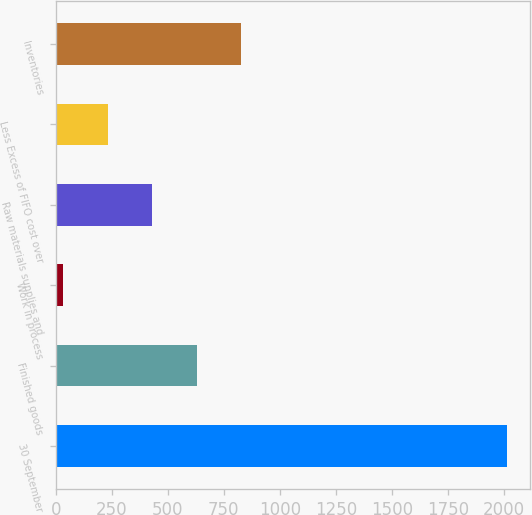Convert chart. <chart><loc_0><loc_0><loc_500><loc_500><bar_chart><fcel>30 September<fcel>Finished goods<fcel>Work in process<fcel>Raw materials supplies and<fcel>Less Excess of FIFO cost over<fcel>Inventories<nl><fcel>2015<fcel>628.58<fcel>34.4<fcel>430.52<fcel>232.46<fcel>826.64<nl></chart> 